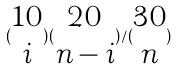<formula> <loc_0><loc_0><loc_500><loc_500>( \begin{matrix} 1 0 \\ i \end{matrix} ) ( \begin{matrix} 2 0 \\ n - i \end{matrix} ) / ( \begin{matrix} 3 0 \\ n \end{matrix} )</formula> 